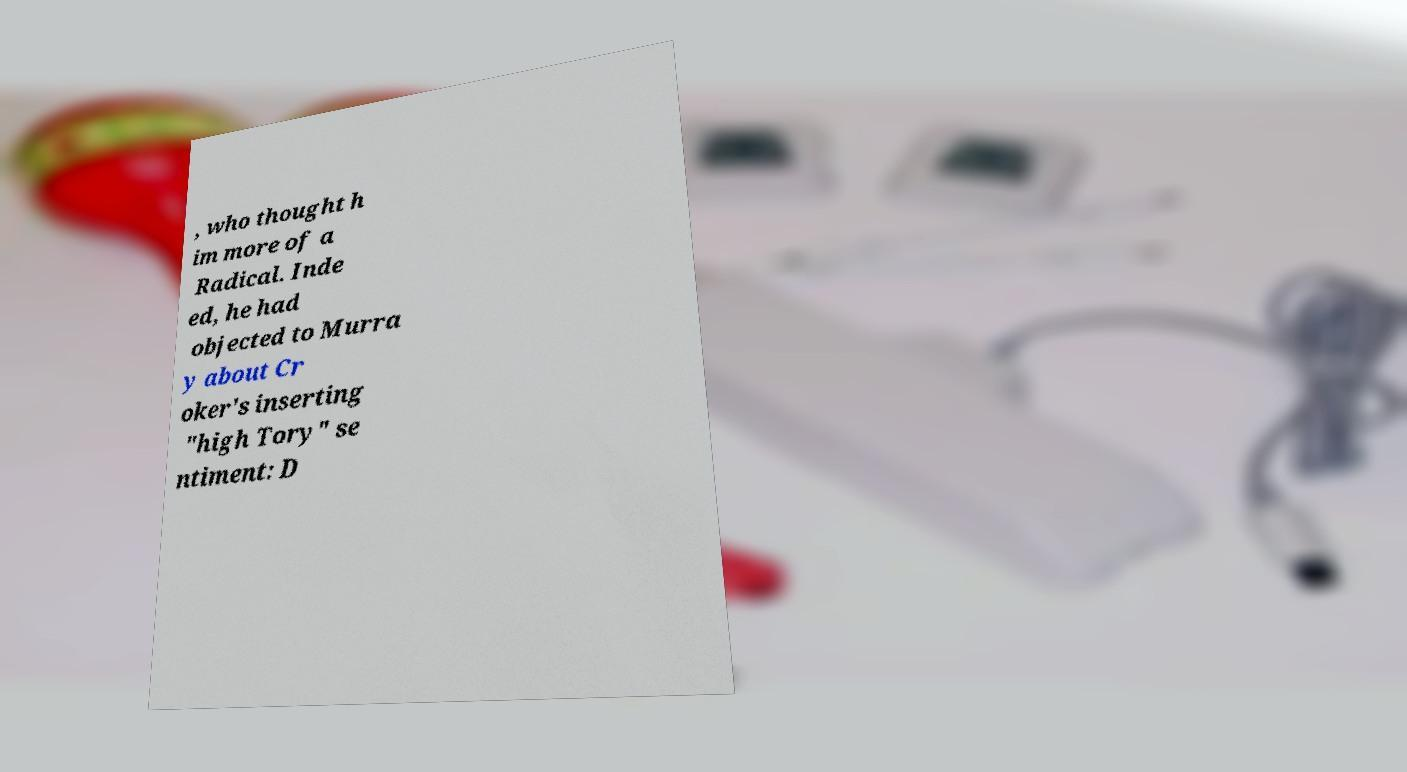Could you extract and type out the text from this image? , who thought h im more of a Radical. Inde ed, he had objected to Murra y about Cr oker's inserting "high Tory" se ntiment: D 